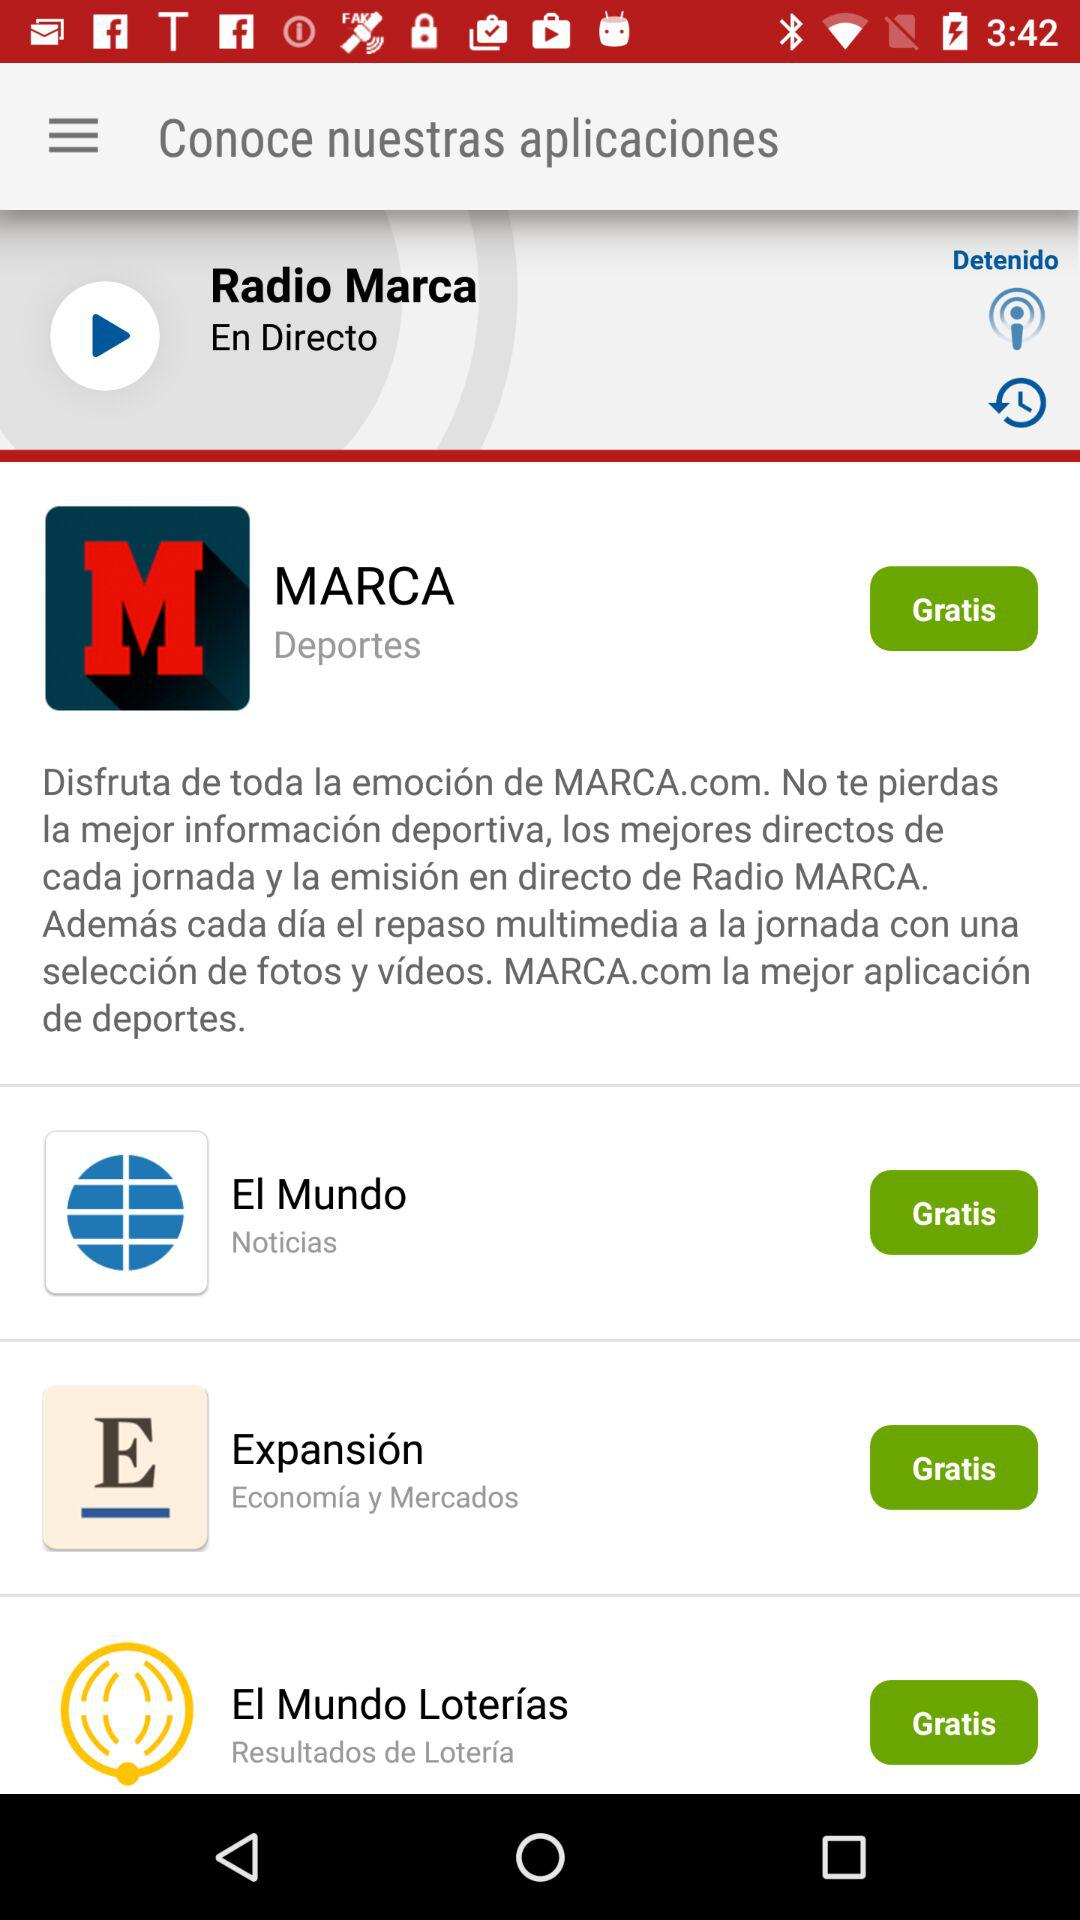How many applications are there on the home screen?
Answer the question using a single word or phrase. 4 